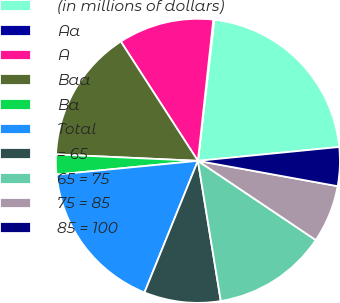<chart> <loc_0><loc_0><loc_500><loc_500><pie_chart><fcel>(in millions of dollars)<fcel>Aa<fcel>A<fcel>Baa<fcel>Ba<fcel>Total<fcel>= 65<fcel>65 = 75<fcel>75 = 85<fcel>85 = 100<nl><fcel>21.6%<fcel>0.12%<fcel>10.86%<fcel>15.15%<fcel>2.27%<fcel>17.32%<fcel>8.71%<fcel>13.01%<fcel>6.56%<fcel>4.41%<nl></chart> 